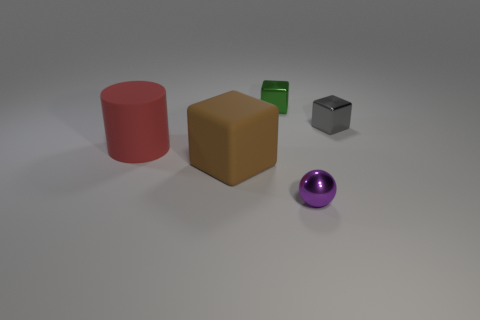How many blocks are either tiny gray objects or tiny shiny objects?
Provide a succinct answer. 2. The small metallic thing that is on the left side of the small gray metal thing and in front of the green metal thing has what shape?
Keep it short and to the point. Sphere. Is there another cylinder that has the same size as the rubber cylinder?
Your answer should be compact. No. How many objects are either large rubber things that are behind the brown block or large matte blocks?
Make the answer very short. 2. Does the small ball have the same material as the thing that is on the left side of the brown block?
Your answer should be very brief. No. What number of other objects are there of the same shape as the purple object?
Your response must be concise. 0. What number of objects are tiny things that are to the left of the tiny purple thing or things behind the tiny gray cube?
Your answer should be very brief. 1. How many other objects are there of the same color as the shiny ball?
Offer a terse response. 0. Are there fewer purple spheres that are left of the big cylinder than gray objects to the left of the small gray cube?
Give a very brief answer. No. What number of big blocks are there?
Your response must be concise. 1. 